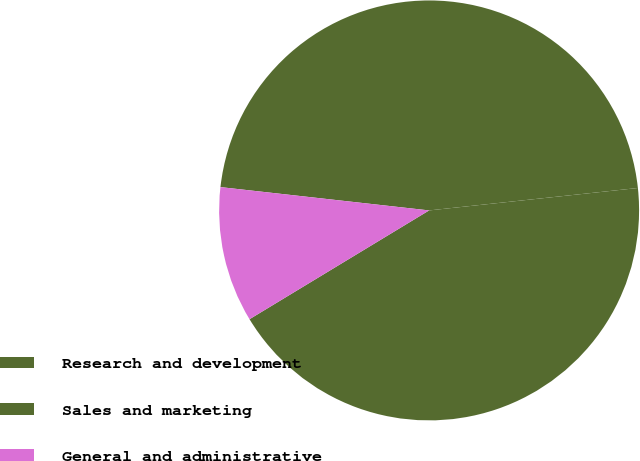<chart> <loc_0><loc_0><loc_500><loc_500><pie_chart><fcel>Research and development<fcel>Sales and marketing<fcel>General and administrative<nl><fcel>46.53%<fcel>43.04%<fcel>10.44%<nl></chart> 